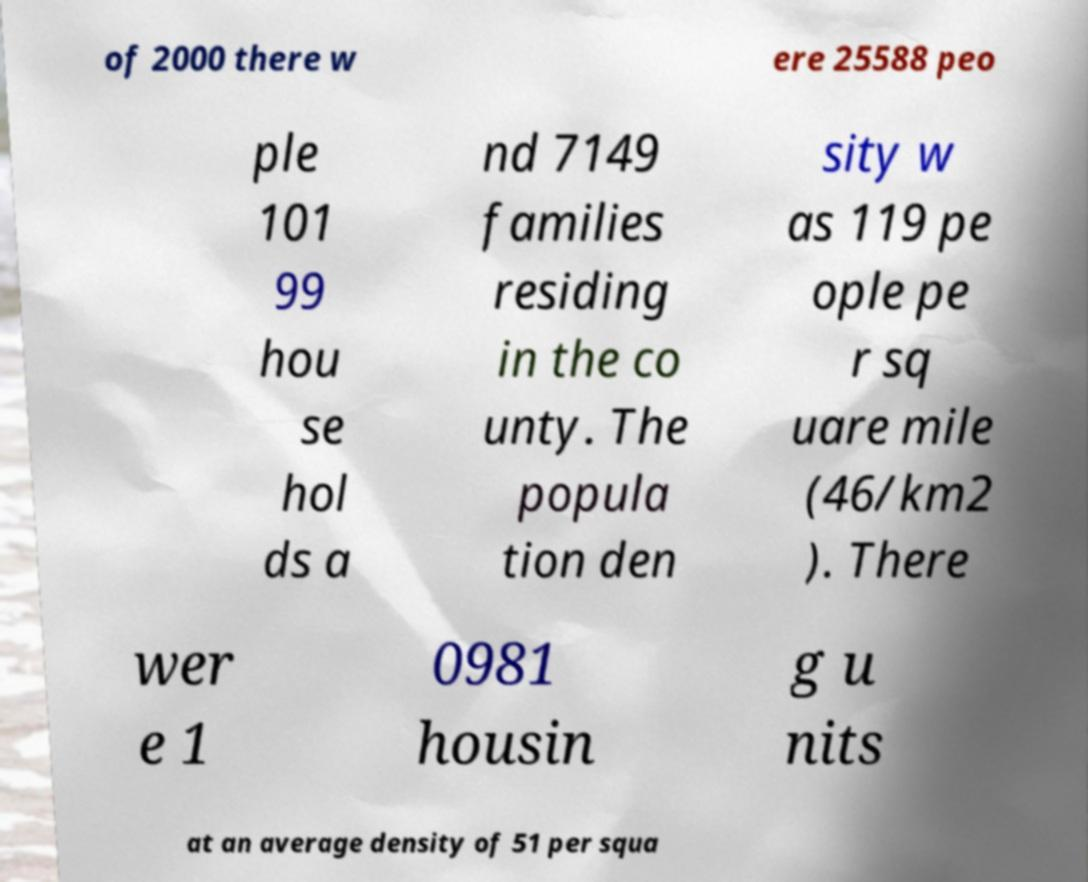I need the written content from this picture converted into text. Can you do that? of 2000 there w ere 25588 peo ple 101 99 hou se hol ds a nd 7149 families residing in the co unty. The popula tion den sity w as 119 pe ople pe r sq uare mile (46/km2 ). There wer e 1 0981 housin g u nits at an average density of 51 per squa 